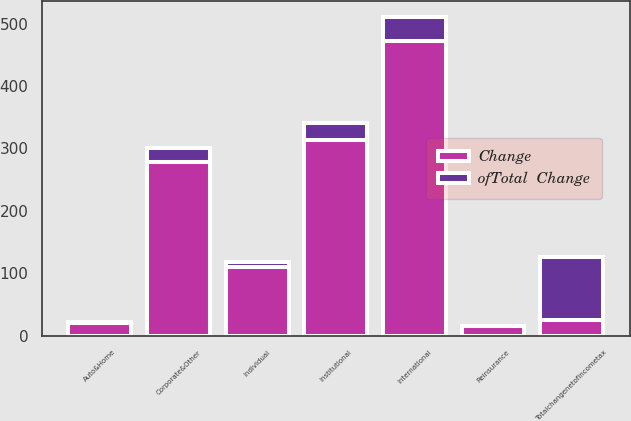Convert chart. <chart><loc_0><loc_0><loc_500><loc_500><stacked_bar_chart><ecel><fcel>International<fcel>Institutional<fcel>Corporate&Other<fcel>Individual<fcel>Auto&Home<fcel>Reinsurance<fcel>Totalchangenetofincometax<nl><fcel>Change<fcel>472<fcel>314<fcel>278<fcel>110<fcel>20<fcel>15<fcel>26<nl><fcel>ofTotal  Change<fcel>39<fcel>26<fcel>23<fcel>9<fcel>2<fcel>1<fcel>100<nl></chart> 